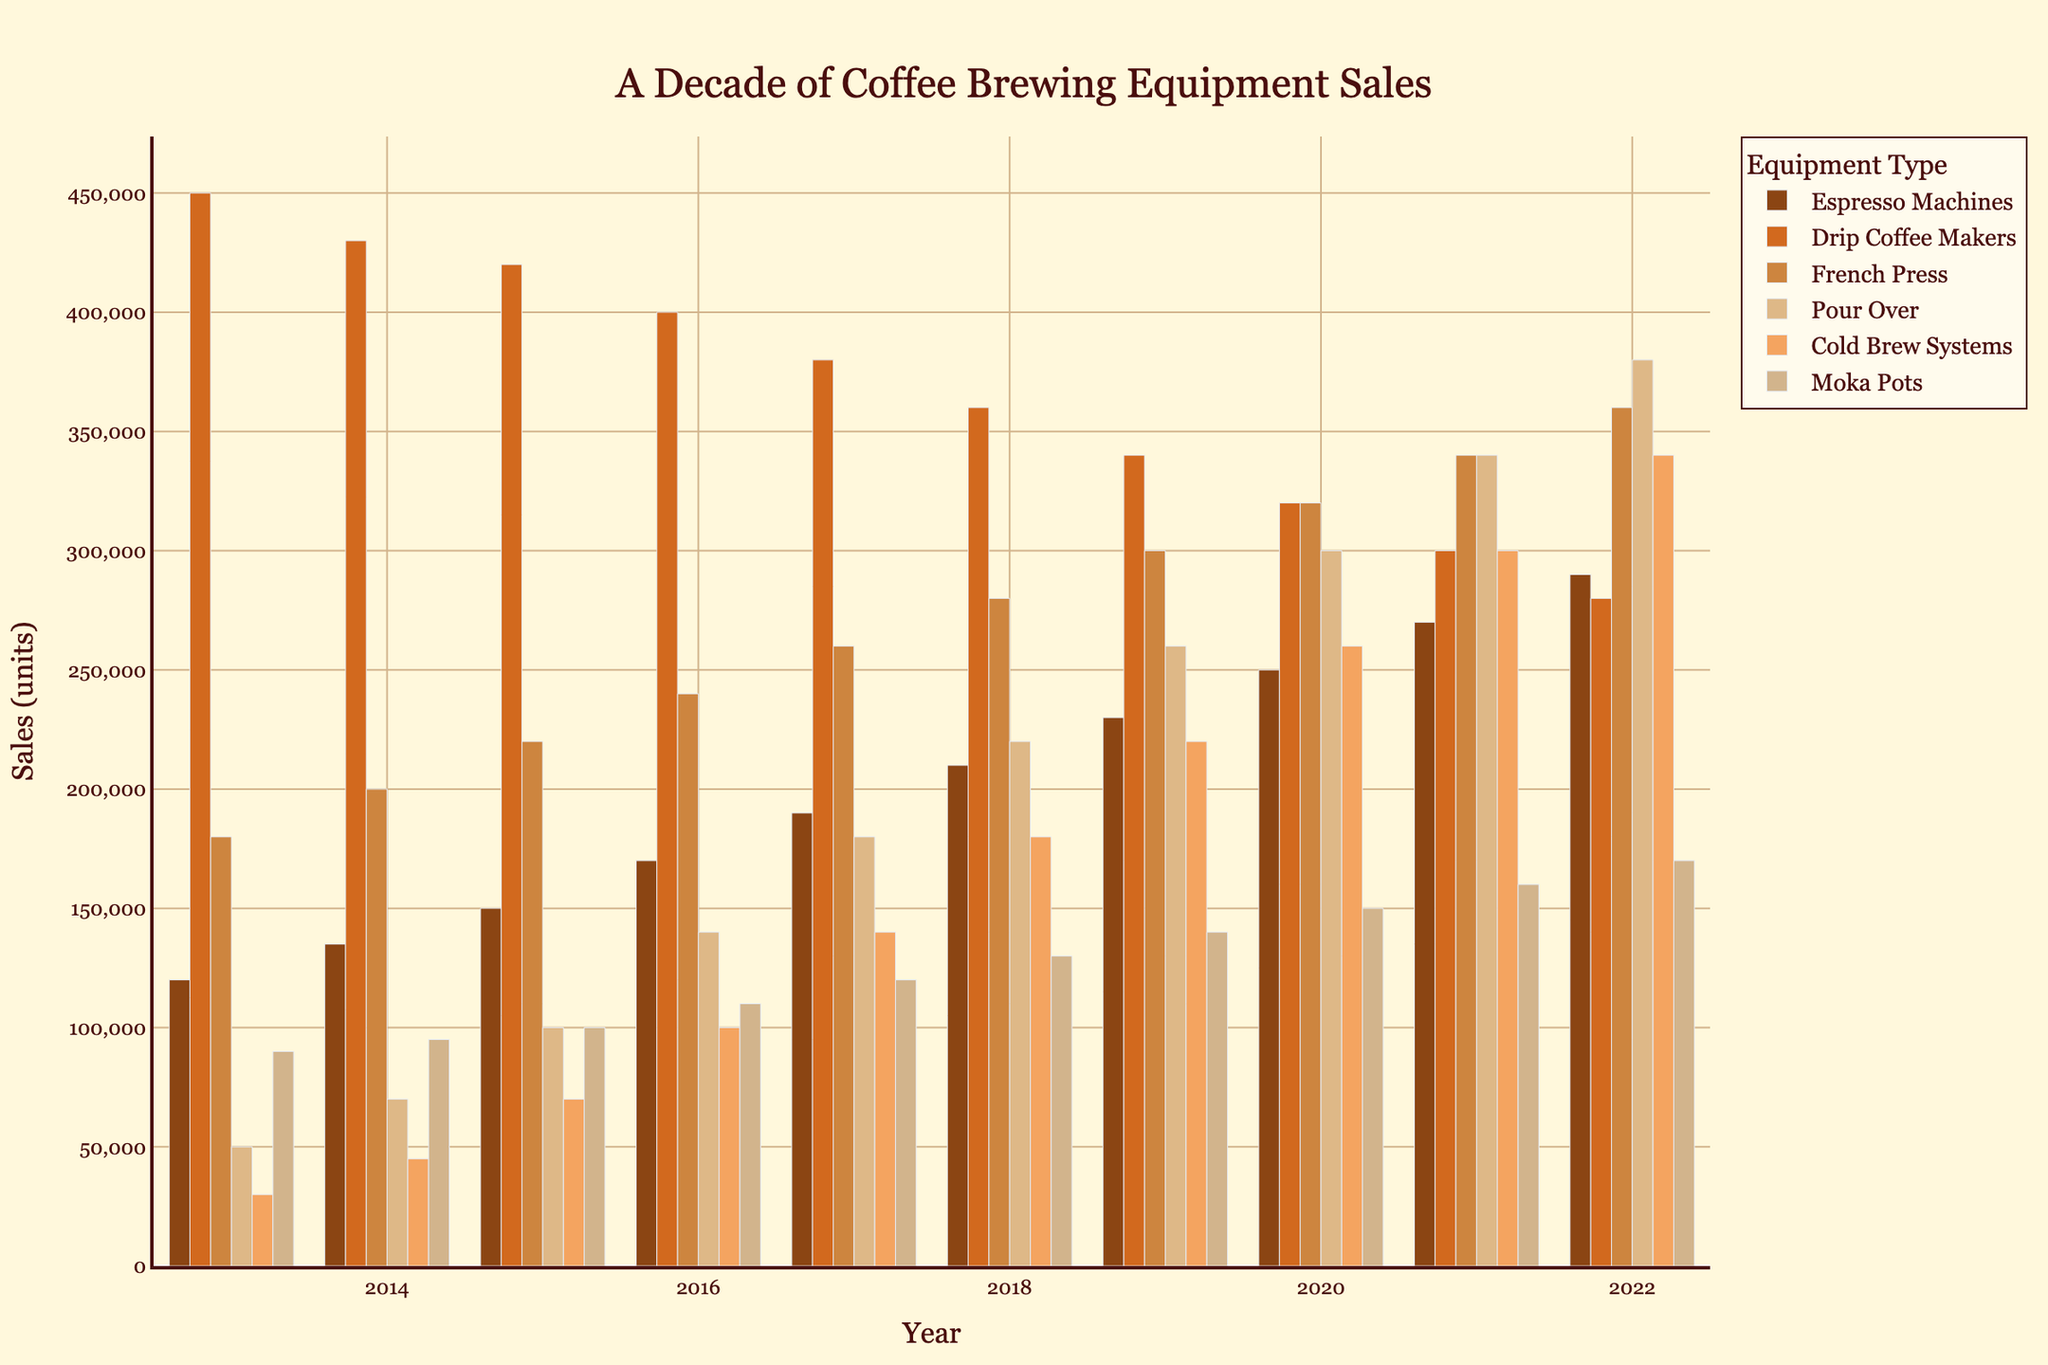What was the total sales of French Press and Pour Over in 2015? First, identify the sales of French Press in 2015, which is 220,000 units. Next, find the sales of Pour Over in 2015, which is 100,000 units. Sum these values: 220,000 + 100,000 = 320,000.
Answer: 320,000 Which type of equipment had the highest sales in 2022? Look at the sales values for all equipment types in 2022: Espresso Machines (290,000), Drip Coffee Makers (280,000), French Press (360,000), Pour Over (380,000), Cold Brew Systems (340,000), and Moka Pots (170,000). Pour Over has the highest value with 380,000 units.
Answer: Pour Over In which year did Cold Brew Systems have a sales spike where sales doubled compared to the previous year? Check the sales data for Cold Brew Systems year by year. From 2016 to 2017, sales increased from 100,000 to 140,000 units, not double. From 2017 to 2018, sales increased from 140,000 to 180,000 units, also not double. From 2018 to 2019, sales increased from 180,000 to 220,000 units, not double. The year from 2019 to 2020, sales increased from 220,000 to 260,000 units, not double. Thus, no year had sales double the previous year.
Answer: No year Which equipment's sales were consistently increasing every year over the decade? Review each equipment type year by year. The sales for Espresso Machines consistently increase each year from 120,000 in 2013 to 290,000 in 2022.
Answer: Espresso Machines What is the difference between the highest and lowest sales values for Moka Pots over the decade? Identify the highest sales for Moka Pots (which is 170,000 units in 2022) and the lowest sales (which is 90,000 units in 2013). The difference is calculated as 170,000 - 90,000 = 80,000.
Answer: 80,000 What was the average yearly sales of Drip Coffee Makers in the last 5 years? Calculate the sales for Drip Coffee Makers from 2018 to 2022: 360,000 (2018), 340,000 (2019), 320,000 (2020), 300,000 (2021), and 280,000 (2022). Sum these values (360,000 + 340,000 + 320,000 + 300,000 + 280,000 = 1,600,000). Divide the total by 5 to find the average, 1,600,000 / 5 = 320,000.
Answer: 320,000 Between which two consecutive years did Pour Over see the highest growth in sales? Examine the yearly sales data for Pour Over. Calculate the growth between each pair of consecutive years: 2014-2013 (70,000 - 50,000 = 20,000), 2015-2014 (100,000 - 70,000 = 30,000), 2016-2015 (140,000 - 100,000 = 40,000), 2017-2016 (180,000 - 140,000 = 40,000), 2018-2017 (220,000 - 180,000 = 40,000), 2019-2018 (260,000 - 220,000 = 40,000), 2020-2019 (300,000 - 260,000 = 40,000), 2021-2020 (340,000 - 300,000 = 40,000), 2022-2021 (380,000 - 340,000 = 40,000). The highest growth of 40,000 units occurred from 2015 to 2016, 2016 to 2017, 2017 to 2018, 2018 to 2019, 2019 to 2020, 2020 to 2021, and 2021 to 2022.
Answer: Multiple intervals with highest growth How did the sales trend for Drip Coffee Makers change over the decade? Observe the sales trend for Drip Coffee Makers year by year: starting from 450,000 in 2013 and decreasing each year until it reaches 280,000 in 2022. The trend is a consistent decline.
Answer: Declined What was the percentage increase of French Press sales from 2013 to 2022? Identify the sales of French Press in 2013 (180,000) and in 2022 (360,000). Calculate the percentage increase as ((360,000 - 180,000) / 180,000) * 100 = 100%.
Answer: 100% 